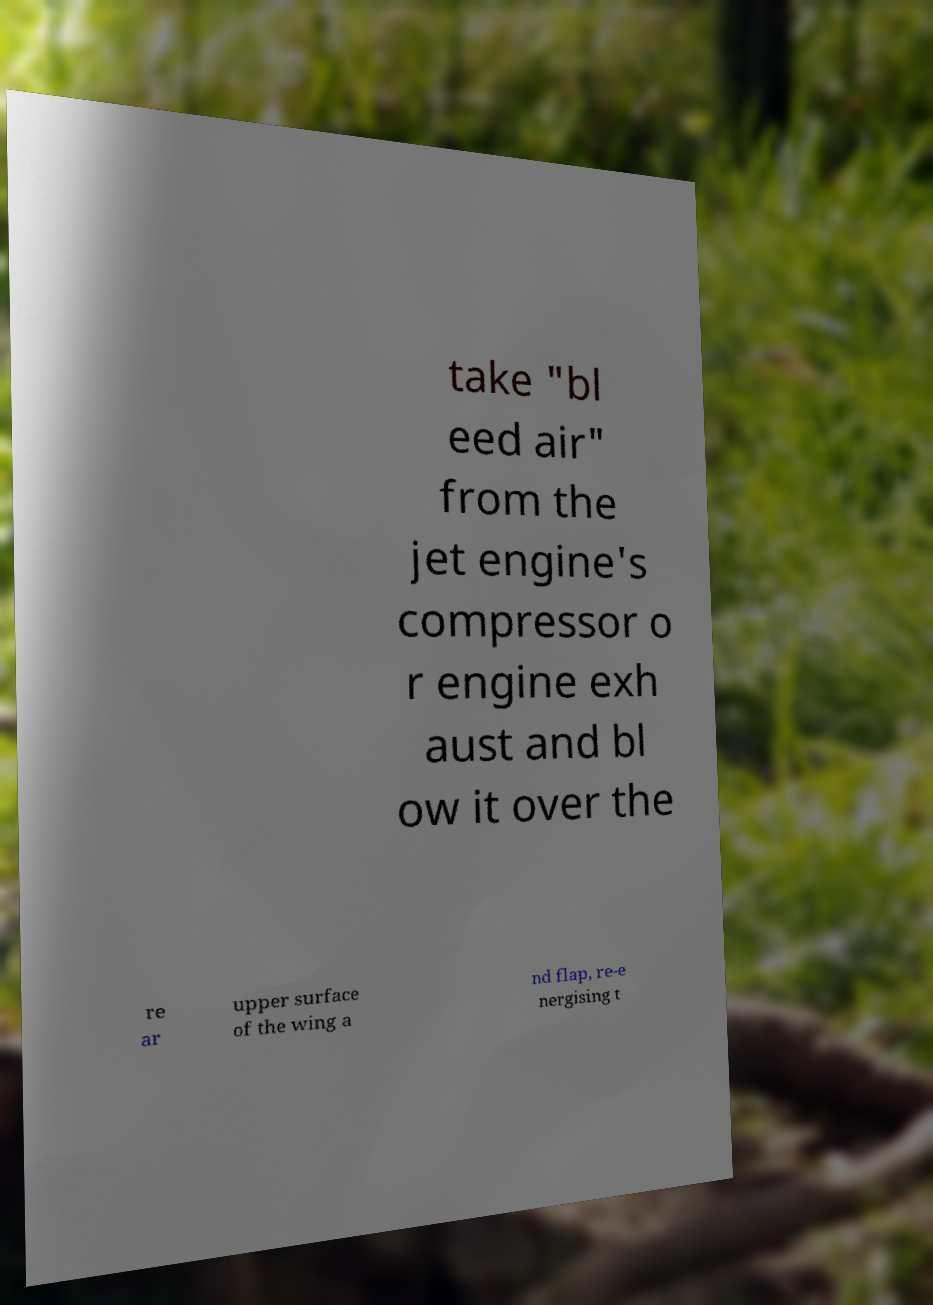Can you read and provide the text displayed in the image?This photo seems to have some interesting text. Can you extract and type it out for me? take "bl eed air" from the jet engine's compressor o r engine exh aust and bl ow it over the re ar upper surface of the wing a nd flap, re-e nergising t 